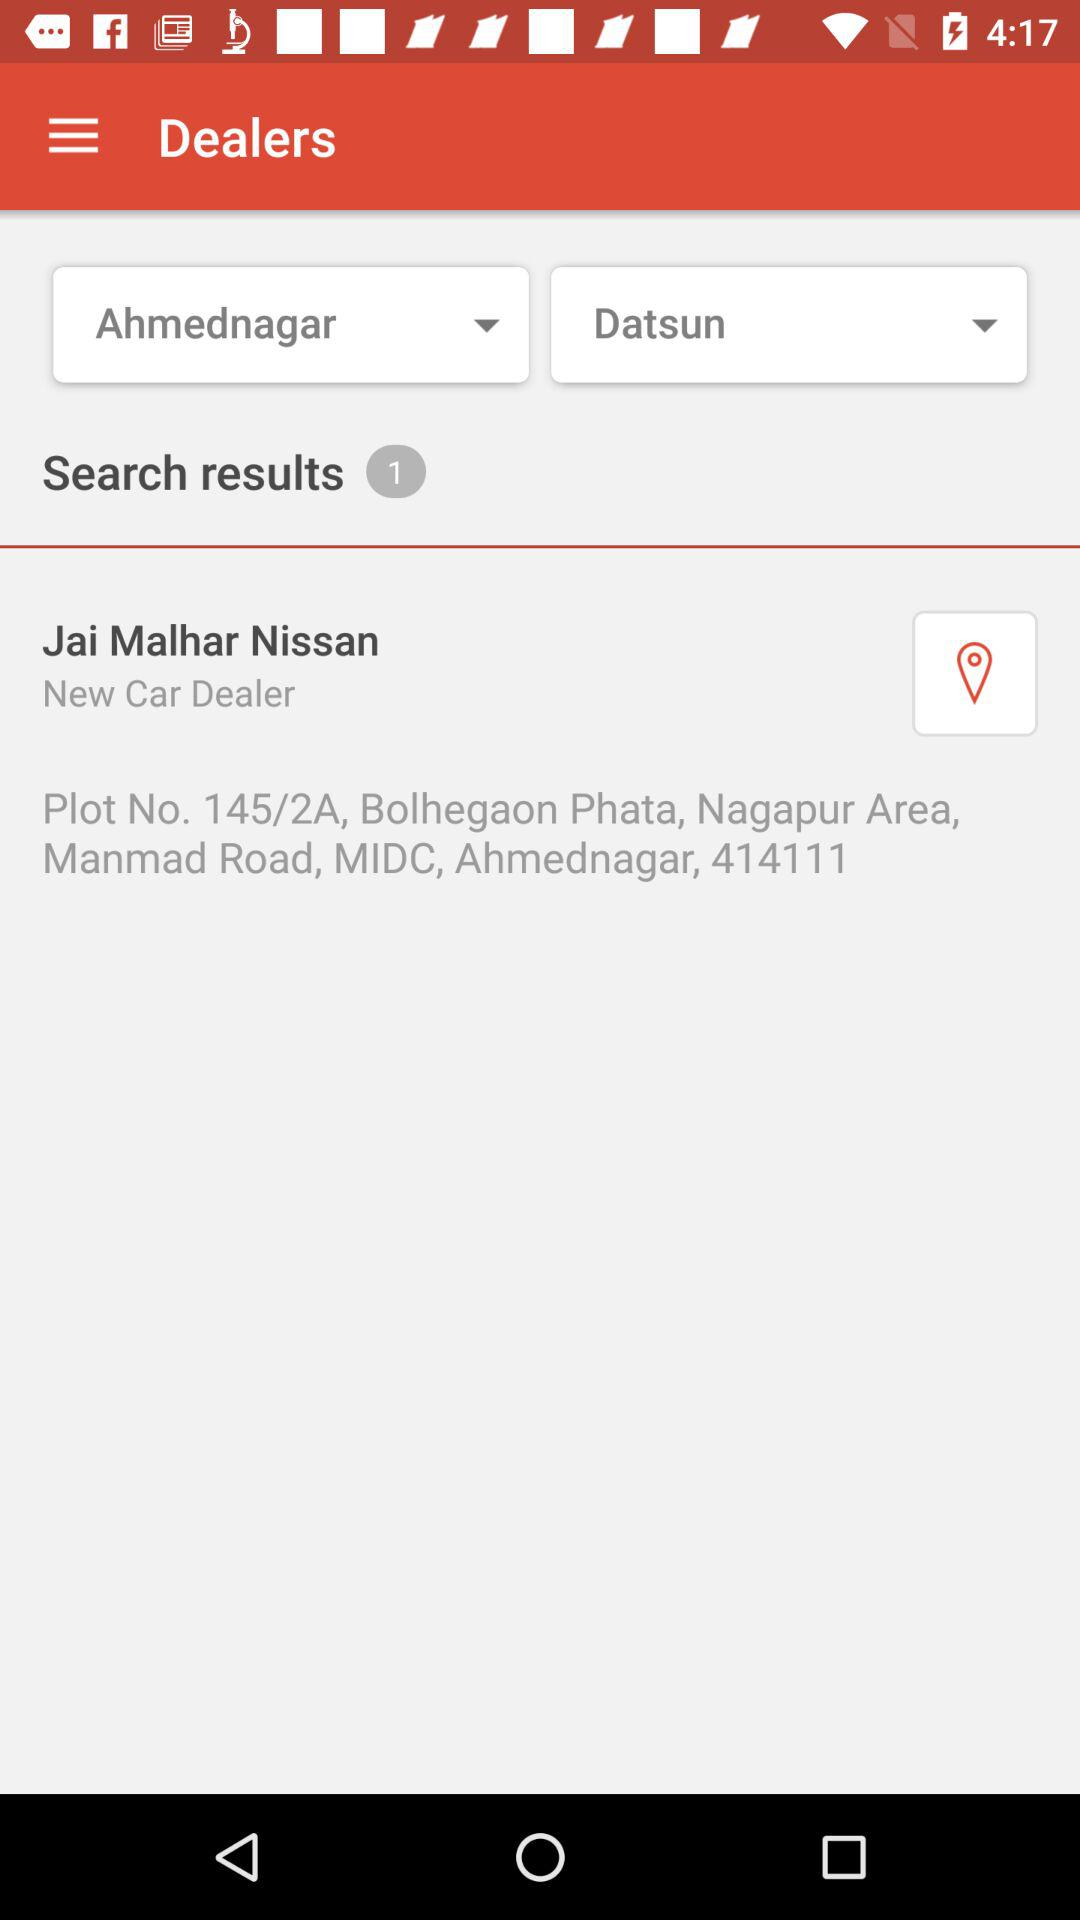What is the name of the "Datsun" dealer in Ahmednagar? The name of the "Datsun" dealer in Ahmednagar is "Jai Malhar Nissan". 